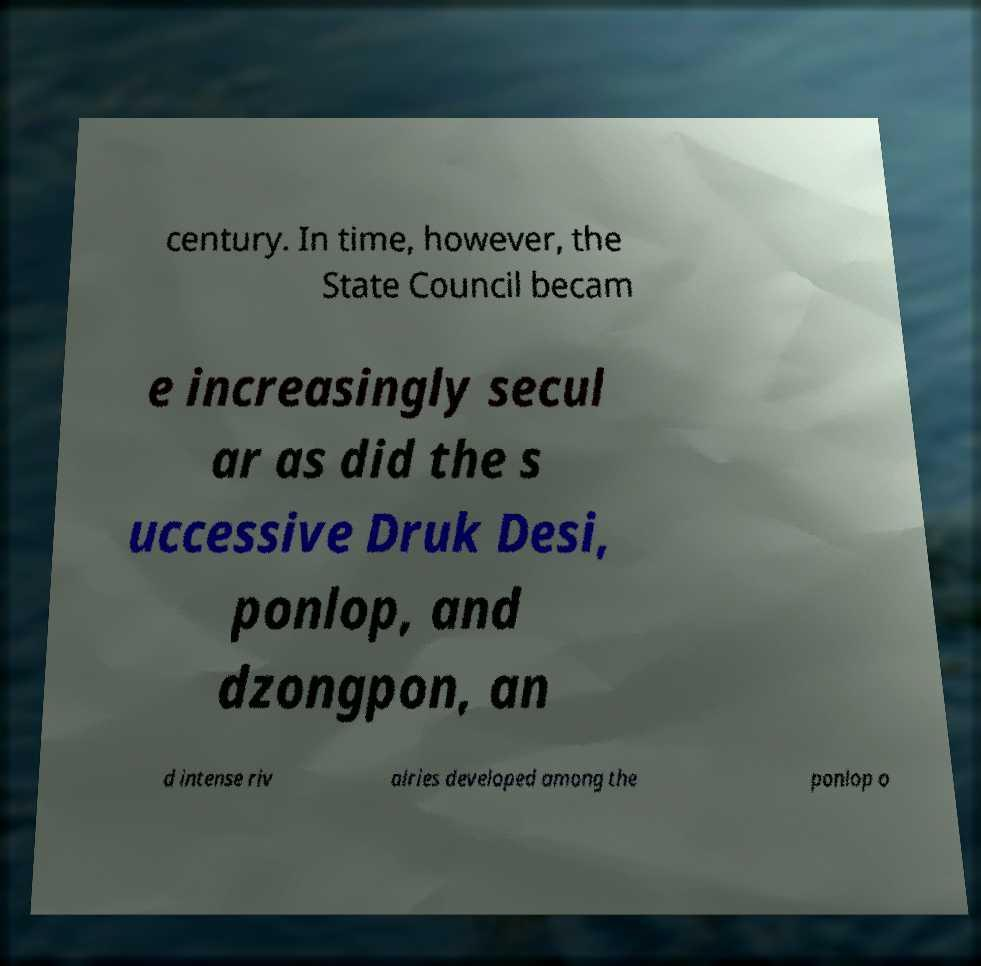Please read and relay the text visible in this image. What does it say? century. In time, however, the State Council becam e increasingly secul ar as did the s uccessive Druk Desi, ponlop, and dzongpon, an d intense riv alries developed among the ponlop o 